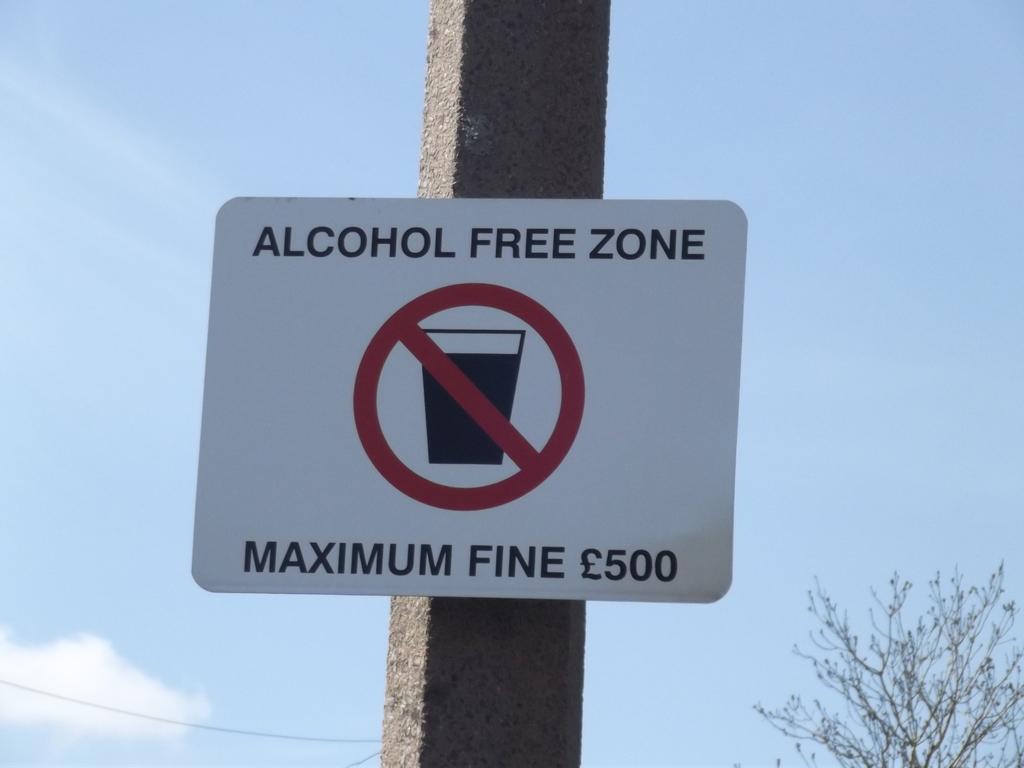What is the fine for violating this rule?
Provide a short and direct response. 500. 